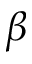<formula> <loc_0><loc_0><loc_500><loc_500>\beta</formula> 